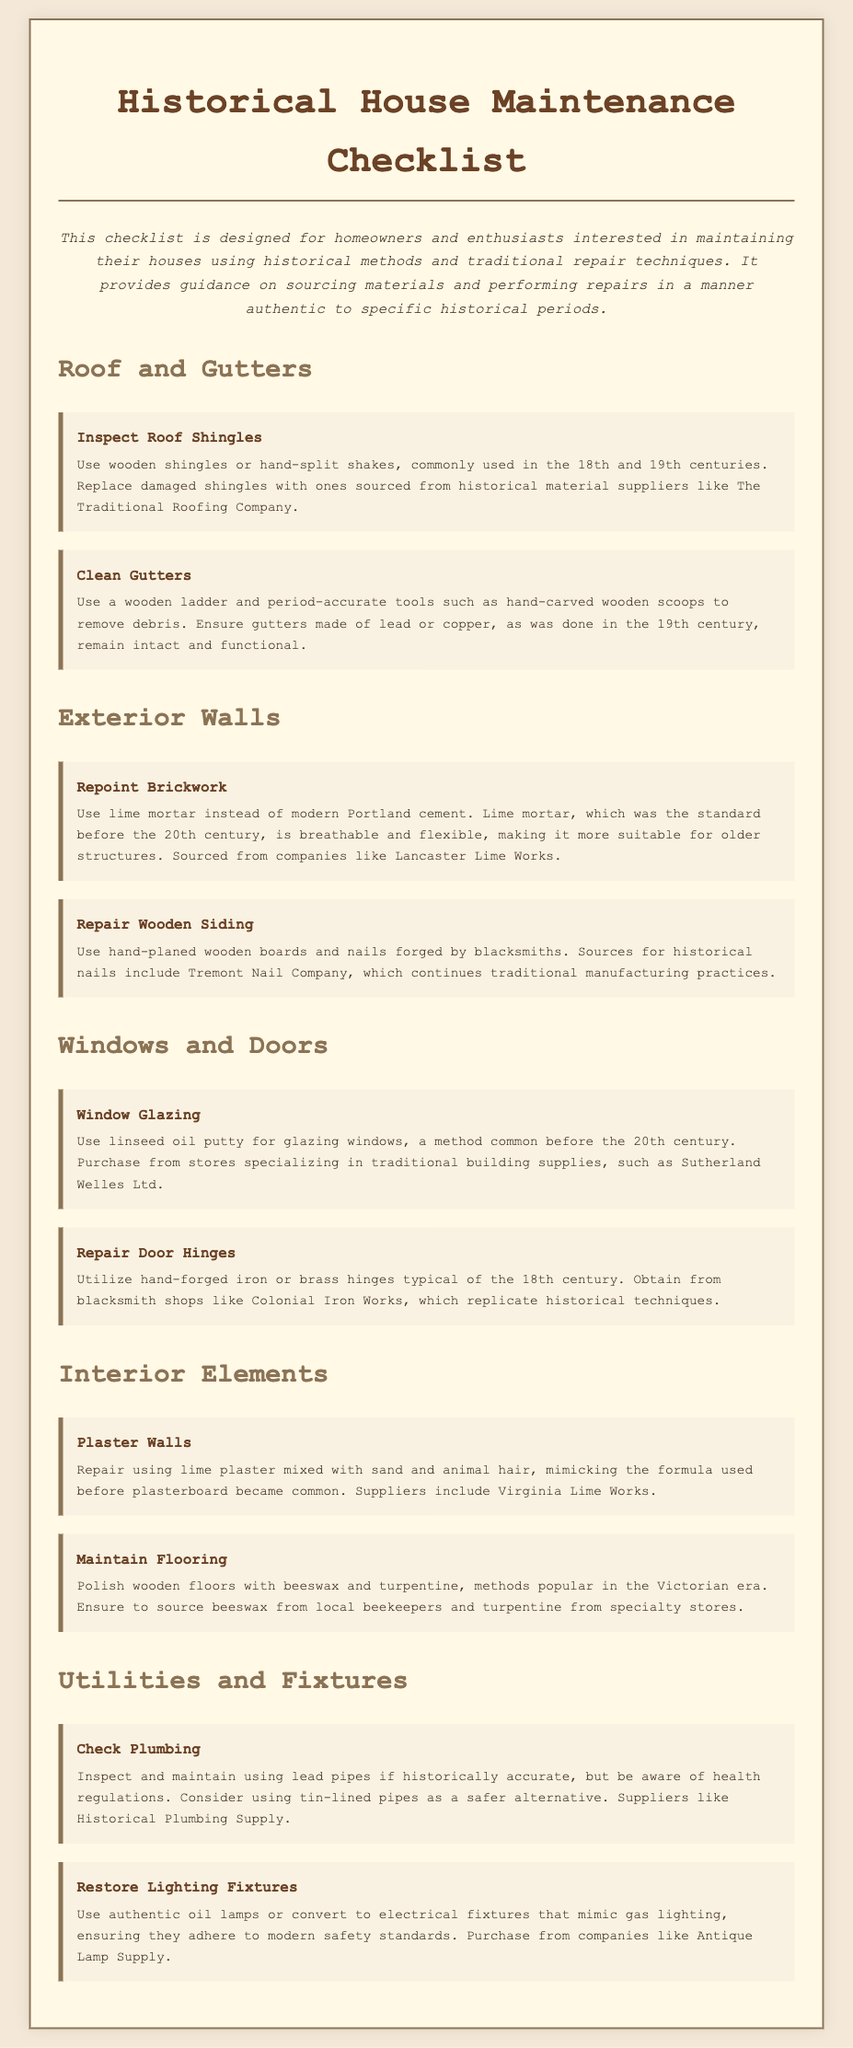What is the first task listed under Roof and Gutters? The first task is "Inspect Roof Shingles," which is listed in the Roof and Gutters section of the document.
Answer: Inspect Roof Shingles What material should be used for repointing brickwork? The document specifies using lime mortar instead of modern Portland cement for repointing brickwork.
Answer: Lime mortar Which company supplies hand-forged iron or brass hinges? The document mentions Colonial Iron Works as a supplier of hand-forged iron or brass hinges.
Answer: Colonial Iron Works What is the method suggested for polishing wooden floors? The document states that wooden floors can be polished with beeswax and turpentine, methods popular in the Victorian era.
Answer: Beeswax and turpentine How many tasks are listed under Utilities and Fixtures? There are two tasks listed under Utilities and Fixtures: "Check Plumbing" and "Restore Lighting Fixtures."
Answer: Two 